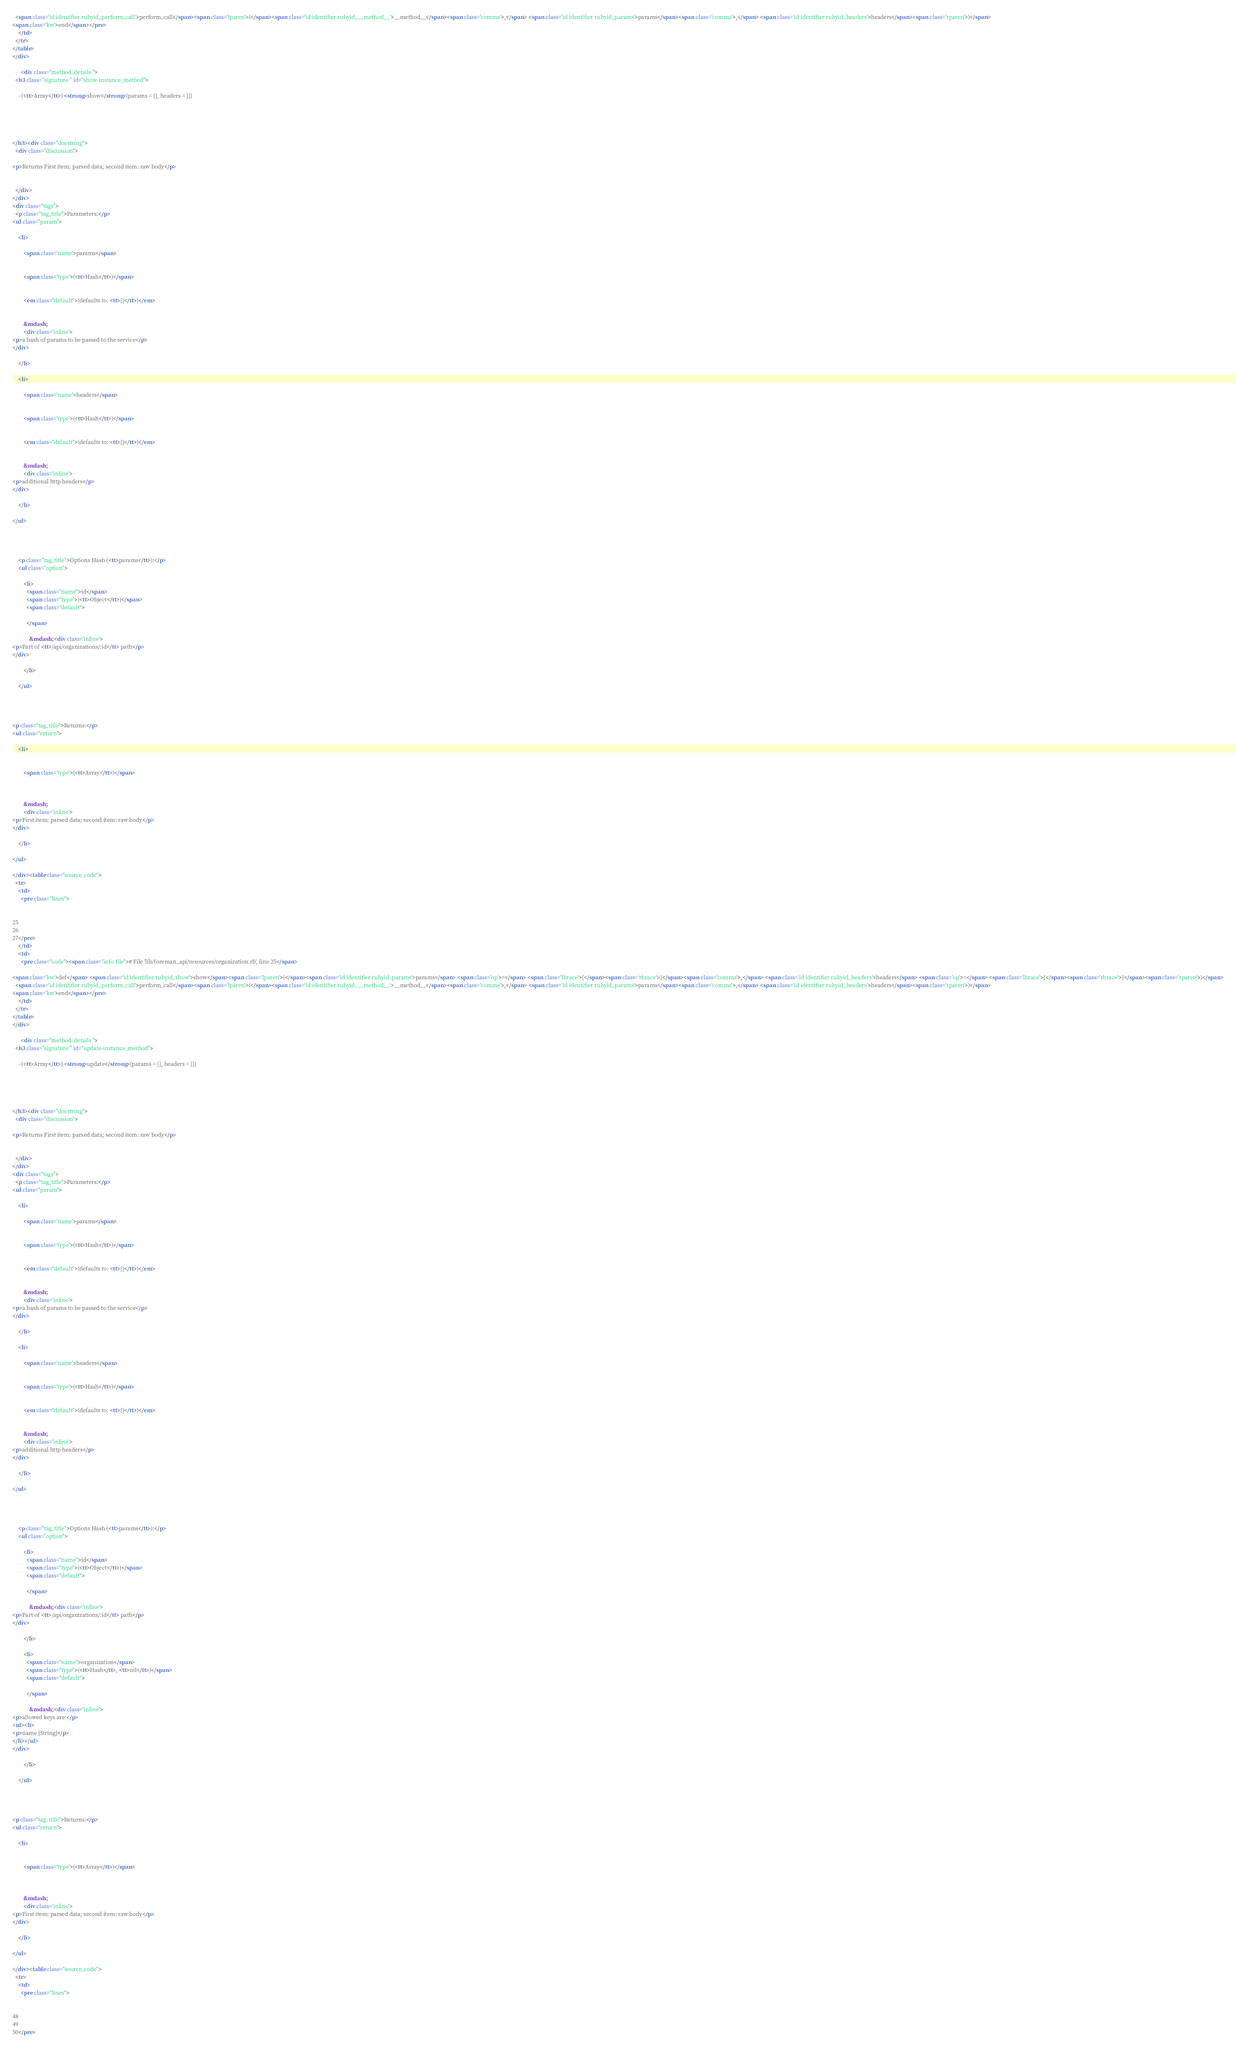<code> <loc_0><loc_0><loc_500><loc_500><_HTML_>  <span class='id identifier rubyid_perform_call'>perform_call</span><span class='lparen'>(</span><span class='id identifier rubyid___method__'>__method__</span><span class='comma'>,</span> <span class='id identifier rubyid_params'>params</span><span class='comma'>,</span> <span class='id identifier rubyid_headers'>headers</span><span class='rparen'>)</span>
<span class='kw'>end</span></pre>
    </td>
  </tr>
</table>
</div>
    
      <div class="method_details ">
  <h3 class="signature " id="show-instance_method">
  
    - (<tt>Array</tt>) <strong>show</strong>(params = {}, headers = {}) 
  

  

  
</h3><div class="docstring">
  <div class="discussion">
    
<p>Returns First item: parsed data; second item: raw body</p>


  </div>
</div>
<div class="tags">
  <p class="tag_title">Parameters:</p>
<ul class="param">
  
    <li>
      
        <span class='name'>params</span>
      
      
        <span class='type'>(<tt>Hash</tt>)</span>
      
      
        <em class="default">(defaults to: <tt>{}</tt>)</em>
      
      
        &mdash;
        <div class='inline'>
<p>a hash of params to be passed to the service</p>
</div>
      
    </li>
  
    <li>
      
        <span class='name'>headers</span>
      
      
        <span class='type'>(<tt>Hash</tt>)</span>
      
      
        <em class="default">(defaults to: <tt>{}</tt>)</em>
      
      
        &mdash;
        <div class='inline'>
<p>additional http headers</p>
</div>
      
    </li>
  
</ul>

  
    
    
    <p class="tag_title">Options Hash (<tt>params</tt>):</p>
    <ul class="option">
      
        <li>
          <span class="name">id</span>
          <span class="type">(<tt>Object</tt>)</span>
          <span class="default">
            
          </span>
          
            &mdash; <div class='inline'>
<p>Part of <tt>/api/organizations/:id</tt> path</p>
</div>
          
        </li>
      
    </ul>
  
    
    

<p class="tag_title">Returns:</p>
<ul class="return">
  
    <li>
      
      
        <span class='type'>(<tt>Array</tt>)</span>
      
      
      
        &mdash;
        <div class='inline'>
<p>First item: parsed data; second item: raw body</p>
</div>
      
    </li>
  
</ul>

</div><table class="source_code">
  <tr>
    <td>
      <pre class="lines">


25
26
27</pre>
    </td>
    <td>
      <pre class="code"><span class="info file"># File 'lib/foreman_api/resources/organization.rb', line 25</span>

<span class='kw'>def</span> <span class='id identifier rubyid_show'>show</span><span class='lparen'>(</span><span class='id identifier rubyid_params'>params</span> <span class='op'>=</span> <span class='lbrace'>{</span><span class='rbrace'>}</span><span class='comma'>,</span> <span class='id identifier rubyid_headers'>headers</span> <span class='op'>=</span> <span class='lbrace'>{</span><span class='rbrace'>}</span><span class='rparen'>)</span>
  <span class='id identifier rubyid_perform_call'>perform_call</span><span class='lparen'>(</span><span class='id identifier rubyid___method__'>__method__</span><span class='comma'>,</span> <span class='id identifier rubyid_params'>params</span><span class='comma'>,</span> <span class='id identifier rubyid_headers'>headers</span><span class='rparen'>)</span>
<span class='kw'>end</span></pre>
    </td>
  </tr>
</table>
</div>
    
      <div class="method_details ">
  <h3 class="signature " id="update-instance_method">
  
    - (<tt>Array</tt>) <strong>update</strong>(params = {}, headers = {}) 
  

  

  
</h3><div class="docstring">
  <div class="discussion">
    
<p>Returns First item: parsed data; second item: raw body</p>


  </div>
</div>
<div class="tags">
  <p class="tag_title">Parameters:</p>
<ul class="param">
  
    <li>
      
        <span class='name'>params</span>
      
      
        <span class='type'>(<tt>Hash</tt>)</span>
      
      
        <em class="default">(defaults to: <tt>{}</tt>)</em>
      
      
        &mdash;
        <div class='inline'>
<p>a hash of params to be passed to the service</p>
</div>
      
    </li>
  
    <li>
      
        <span class='name'>headers</span>
      
      
        <span class='type'>(<tt>Hash</tt>)</span>
      
      
        <em class="default">(defaults to: <tt>{}</tt>)</em>
      
      
        &mdash;
        <div class='inline'>
<p>additional http headers</p>
</div>
      
    </li>
  
</ul>

  
    
    
    <p class="tag_title">Options Hash (<tt>params</tt>):</p>
    <ul class="option">
      
        <li>
          <span class="name">id</span>
          <span class="type">(<tt>Object</tt>)</span>
          <span class="default">
            
          </span>
          
            &mdash; <div class='inline'>
<p>Part of <tt>/api/organizations/:id</tt> path</p>
</div>
          
        </li>
      
        <li>
          <span class="name">organization</span>
          <span class="type">(<tt>Hash</tt>, <tt>nil</tt>)</span>
          <span class="default">
            
          </span>
          
            &mdash; <div class='inline'>
<p>allowed keys are:</p>
<ul><li>
<p>name [String]</p>
</li></ul>
</div>
          
        </li>
      
    </ul>
  
    
    

<p class="tag_title">Returns:</p>
<ul class="return">
  
    <li>
      
      
        <span class='type'>(<tt>Array</tt>)</span>
      
      
      
        &mdash;
        <div class='inline'>
<p>First item: parsed data; second item: raw body</p>
</div>
      
    </li>
  
</ul>

</div><table class="source_code">
  <tr>
    <td>
      <pre class="lines">


48
49
50</pre></code> 